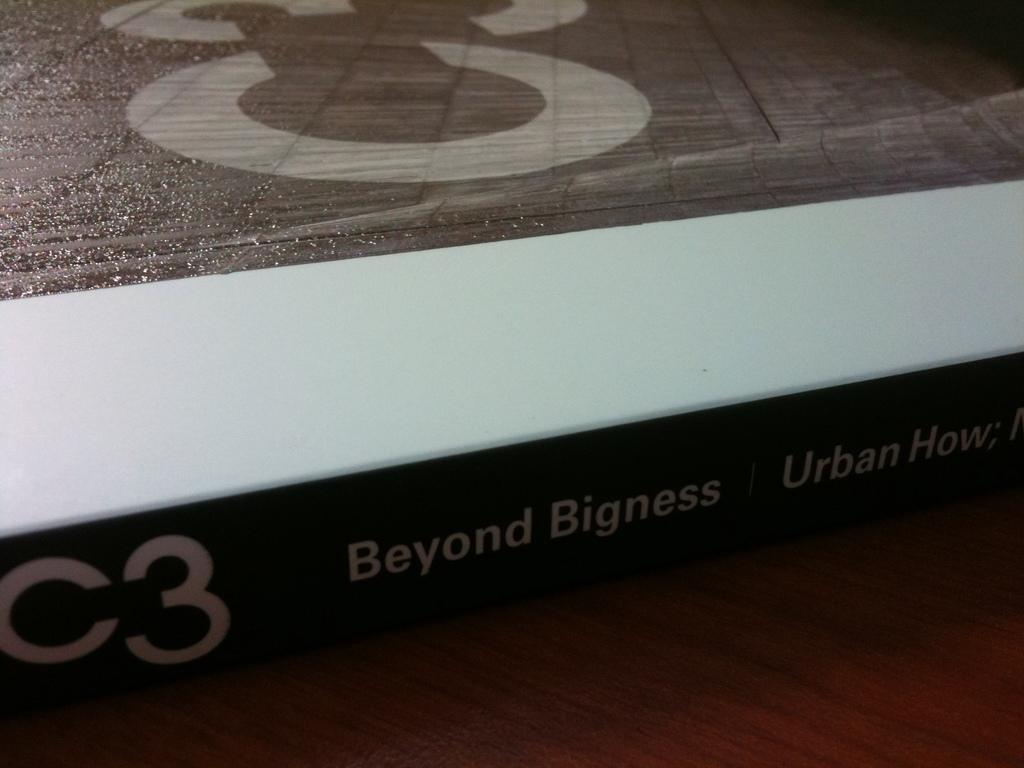<image>
Provide a brief description of the given image. Beyond Bigness is about urban environments and is coded C3. 